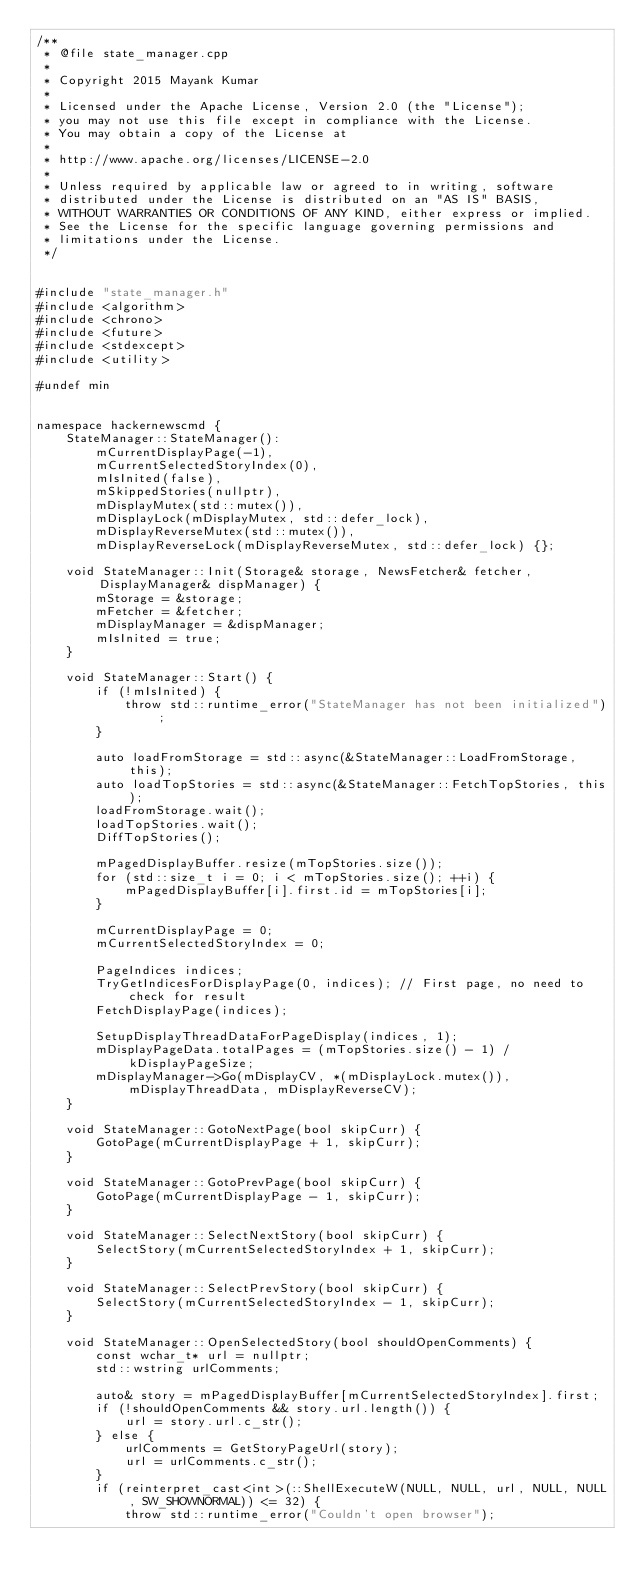<code> <loc_0><loc_0><loc_500><loc_500><_C++_>/**
 * @file state_manager.cpp
 *
 * Copyright 2015 Mayank Kumar
 *
 * Licensed under the Apache License, Version 2.0 (the "License");
 * you may not use this file except in compliance with the License.
 * You may obtain a copy of the License at
 *
 * http://www.apache.org/licenses/LICENSE-2.0
 *
 * Unless required by applicable law or agreed to in writing, software
 * distributed under the License is distributed on an "AS IS" BASIS,
 * WITHOUT WARRANTIES OR CONDITIONS OF ANY KIND, either express or implied.
 * See the License for the specific language governing permissions and
 * limitations under the License.
 */


#include "state_manager.h"
#include <algorithm>
#include <chrono>
#include <future>
#include <stdexcept>
#include <utility>

#undef min


namespace hackernewscmd {
	StateManager::StateManager():
		mCurrentDisplayPage(-1),
		mCurrentSelectedStoryIndex(0),
		mIsInited(false),
		mSkippedStories(nullptr),
		mDisplayMutex(std::mutex()),
		mDisplayLock(mDisplayMutex, std::defer_lock),
		mDisplayReverseMutex(std::mutex()),
		mDisplayReverseLock(mDisplayReverseMutex, std::defer_lock) {};

	void StateManager::Init(Storage& storage, NewsFetcher& fetcher, DisplayManager& dispManager) {
		mStorage = &storage;
		mFetcher = &fetcher;
		mDisplayManager = &dispManager;
		mIsInited = true;
	}

	void StateManager::Start() {
		if (!mIsInited) {
			throw std::runtime_error("StateManager has not been initialized");
		}

		auto loadFromStorage = std::async(&StateManager::LoadFromStorage, this);
		auto loadTopStories = std::async(&StateManager::FetchTopStories, this);
		loadFromStorage.wait();
		loadTopStories.wait();
		DiffTopStories();

		mPagedDisplayBuffer.resize(mTopStories.size());
		for (std::size_t i = 0; i < mTopStories.size(); ++i) {
			mPagedDisplayBuffer[i].first.id = mTopStories[i];
		}

		mCurrentDisplayPage = 0;
		mCurrentSelectedStoryIndex = 0;

		PageIndices indices;
		TryGetIndicesForDisplayPage(0, indices); // First page, no need to check for result
		FetchDisplayPage(indices);

		SetupDisplayThreadDataForPageDisplay(indices, 1);
		mDisplayPageData.totalPages = (mTopStories.size() - 1) / kDisplayPageSize;
		mDisplayManager->Go(mDisplayCV, *(mDisplayLock.mutex()), mDisplayThreadData, mDisplayReverseCV);
	}

	void StateManager::GotoNextPage(bool skipCurr) {
		GotoPage(mCurrentDisplayPage + 1, skipCurr);
	}

	void StateManager::GotoPrevPage(bool skipCurr) {
		GotoPage(mCurrentDisplayPage - 1, skipCurr);
	}

	void StateManager::SelectNextStory(bool skipCurr) {
		SelectStory(mCurrentSelectedStoryIndex + 1, skipCurr);
	}

	void StateManager::SelectPrevStory(bool skipCurr) {
		SelectStory(mCurrentSelectedStoryIndex - 1, skipCurr);
	}

	void StateManager::OpenSelectedStory(bool shouldOpenComments) {
		const wchar_t* url = nullptr;
		std::wstring urlComments;

		auto& story = mPagedDisplayBuffer[mCurrentSelectedStoryIndex].first;
		if (!shouldOpenComments && story.url.length()) {
			url = story.url.c_str();
		} else {
			urlComments = GetStoryPageUrl(story);
			url = urlComments.c_str();
		}
		if (reinterpret_cast<int>(::ShellExecuteW(NULL, NULL, url, NULL, NULL, SW_SHOWNORMAL)) <= 32) {
			throw std::runtime_error("Couldn't open browser");</code> 